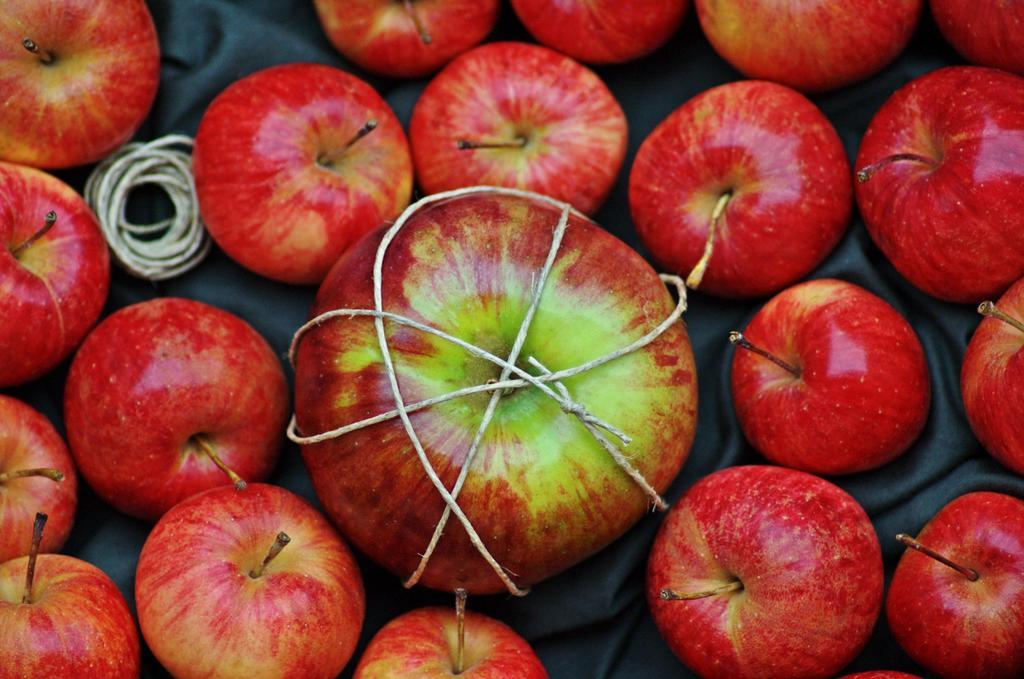What is the main subject in the center of the image? There is an apple in the center of the image. How is the apple in the center of the image being held or displayed? The apple is tied with a thread. What can be seen in the background of the image? There are apples and thread in the background of the image. What other material is present in the background of the image? Cloth is present in the background of the image. How does the judge in the image react to the falling tub? There is no judge or falling tub present in the image; it only features an apple tied with a thread and some background elements. 